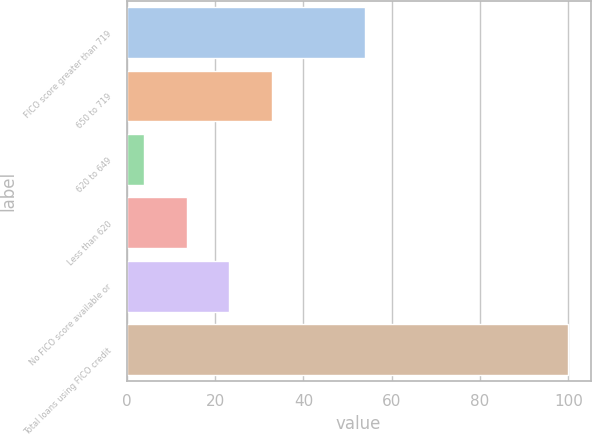Convert chart. <chart><loc_0><loc_0><loc_500><loc_500><bar_chart><fcel>FICO score greater than 719<fcel>650 to 719<fcel>620 to 649<fcel>Less than 620<fcel>No FICO score available or<fcel>Total loans using FICO credit<nl><fcel>54<fcel>32.8<fcel>4<fcel>13.6<fcel>23.2<fcel>100<nl></chart> 